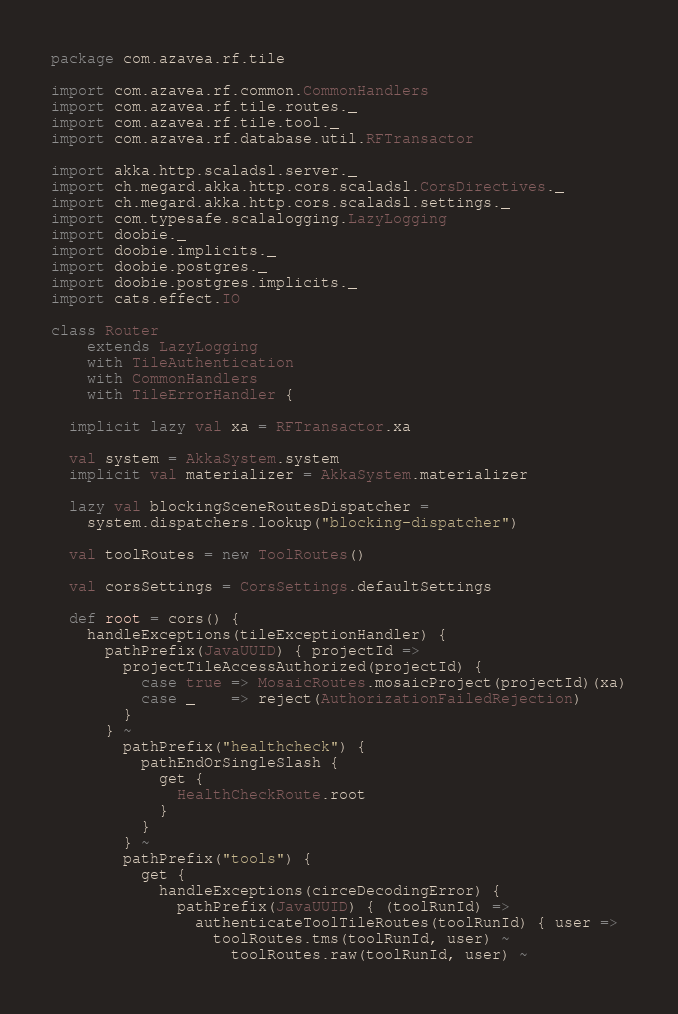Convert code to text. <code><loc_0><loc_0><loc_500><loc_500><_Scala_>package com.azavea.rf.tile

import com.azavea.rf.common.CommonHandlers
import com.azavea.rf.tile.routes._
import com.azavea.rf.tile.tool._
import com.azavea.rf.database.util.RFTransactor

import akka.http.scaladsl.server._
import ch.megard.akka.http.cors.scaladsl.CorsDirectives._
import ch.megard.akka.http.cors.scaladsl.settings._
import com.typesafe.scalalogging.LazyLogging
import doobie._
import doobie.implicits._
import doobie.postgres._
import doobie.postgres.implicits._
import cats.effect.IO

class Router
    extends LazyLogging
    with TileAuthentication
    with CommonHandlers
    with TileErrorHandler {

  implicit lazy val xa = RFTransactor.xa

  val system = AkkaSystem.system
  implicit val materializer = AkkaSystem.materializer

  lazy val blockingSceneRoutesDispatcher =
    system.dispatchers.lookup("blocking-dispatcher")

  val toolRoutes = new ToolRoutes()

  val corsSettings = CorsSettings.defaultSettings

  def root = cors() {
    handleExceptions(tileExceptionHandler) {
      pathPrefix(JavaUUID) { projectId =>
        projectTileAccessAuthorized(projectId) {
          case true => MosaicRoutes.mosaicProject(projectId)(xa)
          case _    => reject(AuthorizationFailedRejection)
        }
      } ~
        pathPrefix("healthcheck") {
          pathEndOrSingleSlash {
            get {
              HealthCheckRoute.root
            }
          }
        } ~
        pathPrefix("tools") {
          get {
            handleExceptions(circeDecodingError) {
              pathPrefix(JavaUUID) { (toolRunId) =>
                authenticateToolTileRoutes(toolRunId) { user =>
                  toolRoutes.tms(toolRunId, user) ~
                    toolRoutes.raw(toolRunId, user) ~</code> 